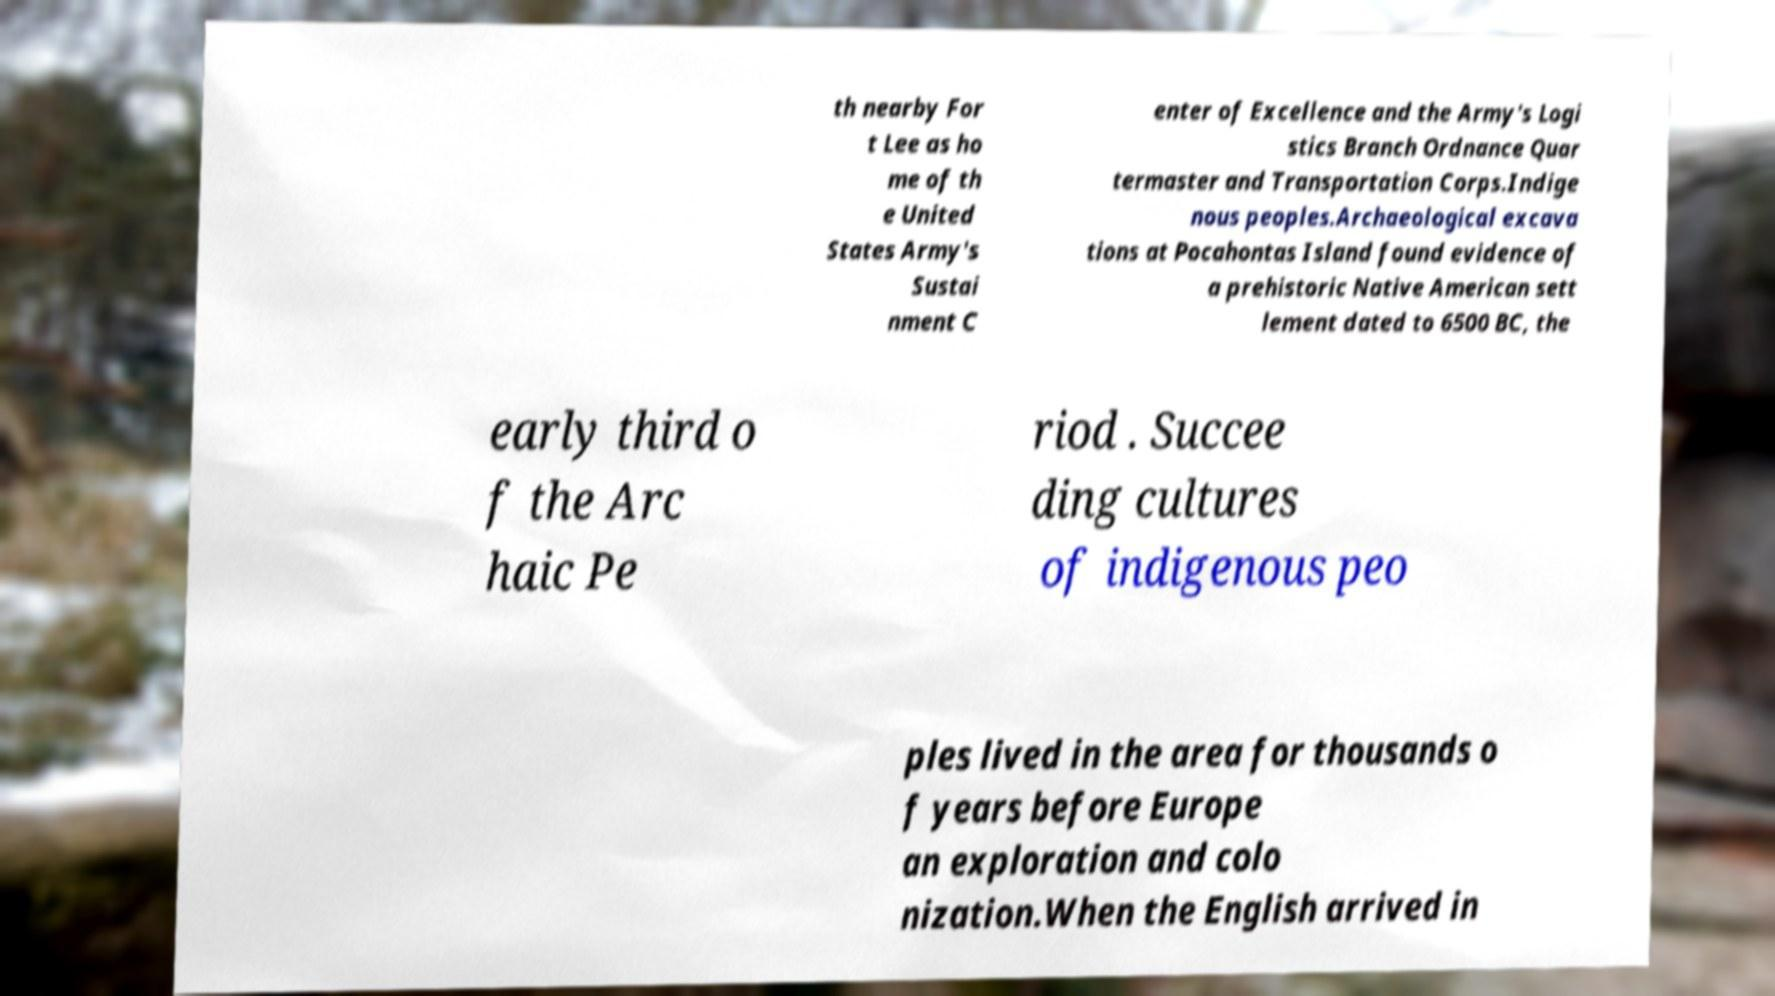There's text embedded in this image that I need extracted. Can you transcribe it verbatim? th nearby For t Lee as ho me of th e United States Army's Sustai nment C enter of Excellence and the Army's Logi stics Branch Ordnance Quar termaster and Transportation Corps.Indige nous peoples.Archaeological excava tions at Pocahontas Island found evidence of a prehistoric Native American sett lement dated to 6500 BC, the early third o f the Arc haic Pe riod . Succee ding cultures of indigenous peo ples lived in the area for thousands o f years before Europe an exploration and colo nization.When the English arrived in 